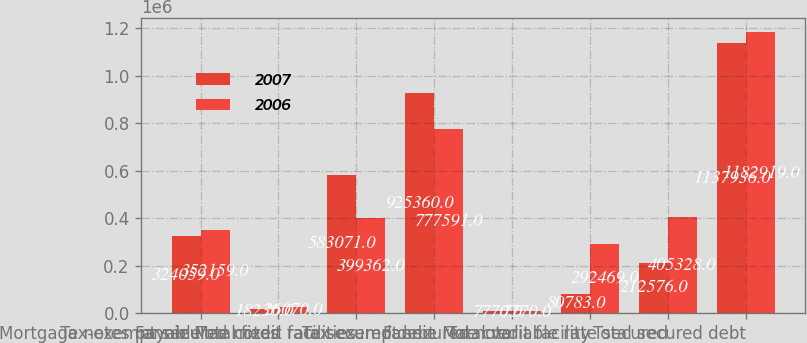Convert chart to OTSL. <chart><loc_0><loc_0><loc_500><loc_500><stacked_bar_chart><ecel><fcel>Mortgage notes payable<fcel>Tax-exempt secured notes<fcel>Fannie Mae credit facilities<fcel>Total fixed rate secured debt<fcel>Tax-exempt secured note<fcel>Fannie Mae credit facility<fcel>Total variable rate secured<fcel>Total secured debt<nl><fcel>2007<fcel>324059<fcel>18230<fcel>583071<fcel>925360<fcel>7770<fcel>80783<fcel>212576<fcel>1.13794e+06<nl><fcel>2006<fcel>352159<fcel>26070<fcel>399362<fcel>777591<fcel>7770<fcel>292469<fcel>405328<fcel>1.18292e+06<nl></chart> 